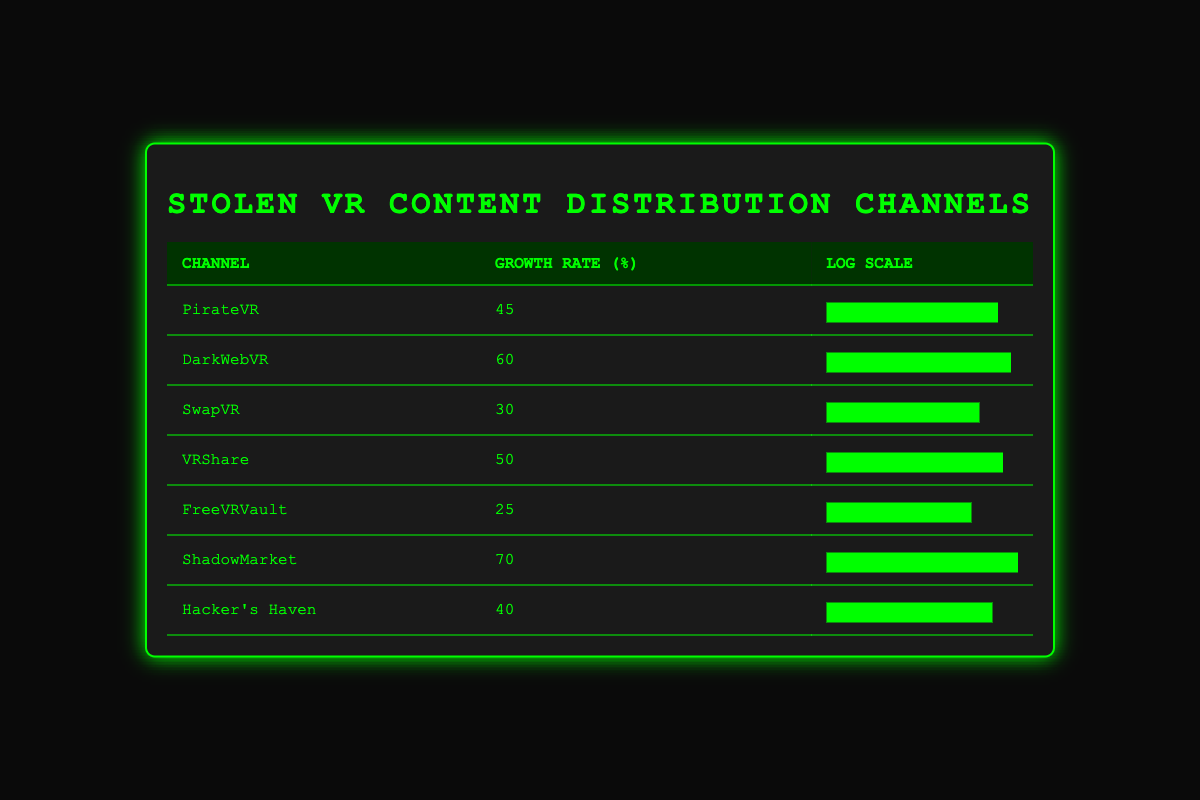What is the growth rate of DarkWebVR? The table lists the growth rate for each distribution channel. For DarkWebVR, the corresponding growth rate value is provided in the second column of the table.
Answer: 60 Which channel has the highest growth rate? By comparing the growth rates of all channels listed in the table, ShadowMarket has the highest value at 70%.
Answer: ShadowMarket What is the average growth rate of all channels listed? To find the average growth rate, we sum all the growth rates: (45 + 60 + 30 + 50 + 25 + 70 + 40) = 320. There are 7 channels, so the average is 320/7 = approximately 45.71.
Answer: 45.71 Is the growth rate of VRShare greater than that of Hacker's Haven? We look at the growth rates for both channels: VRShare has a growth rate of 50%, while Hacker's Haven has a growth rate of 40%. Since 50% is greater than 40%, the statement is true.
Answer: Yes Which two channels have a combined growth rate greater than 100%? We look for pairs of channels to check their combined growth rates. For example, ShadowMarket (70%) and DarkWebVR (60%) combine to give 130%, which is greater than 100%. Thus, this pair meets the condition.
Answer: ShadowMarket and DarkWebVR What is the difference in growth rates between PirateVR and FreeVRVault? The growth rate for PirateVR is 45% and for FreeVRVault, it is 25%. The difference is calculated by subtracting the two values: 45 - 25 = 20.
Answer: 20 Are there any channels with a growth rate less than 30%? By checking each channel's growth rate, we see that FreeVRVault has a rate of 25%, which is less than 30%. Thus, there indeed exists such a channel.
Answer: Yes How many channels have a growth rate of at least 50%? Scanning the growth rates, we find that DarkWebVR (60%), ShadowMarket (70%), and VRShare (50%) all have rates that meet or exceed 50%. Therefore, there are a total of 3 such channels.
Answer: 3 Which channel has a growth rate closest to 40%? We review the growth rates and notice that Hacker's Haven has a growth rate of 40%, which is exactly the target value. Thus, it is the only channel at that specific rate.
Answer: Hacker's Haven 